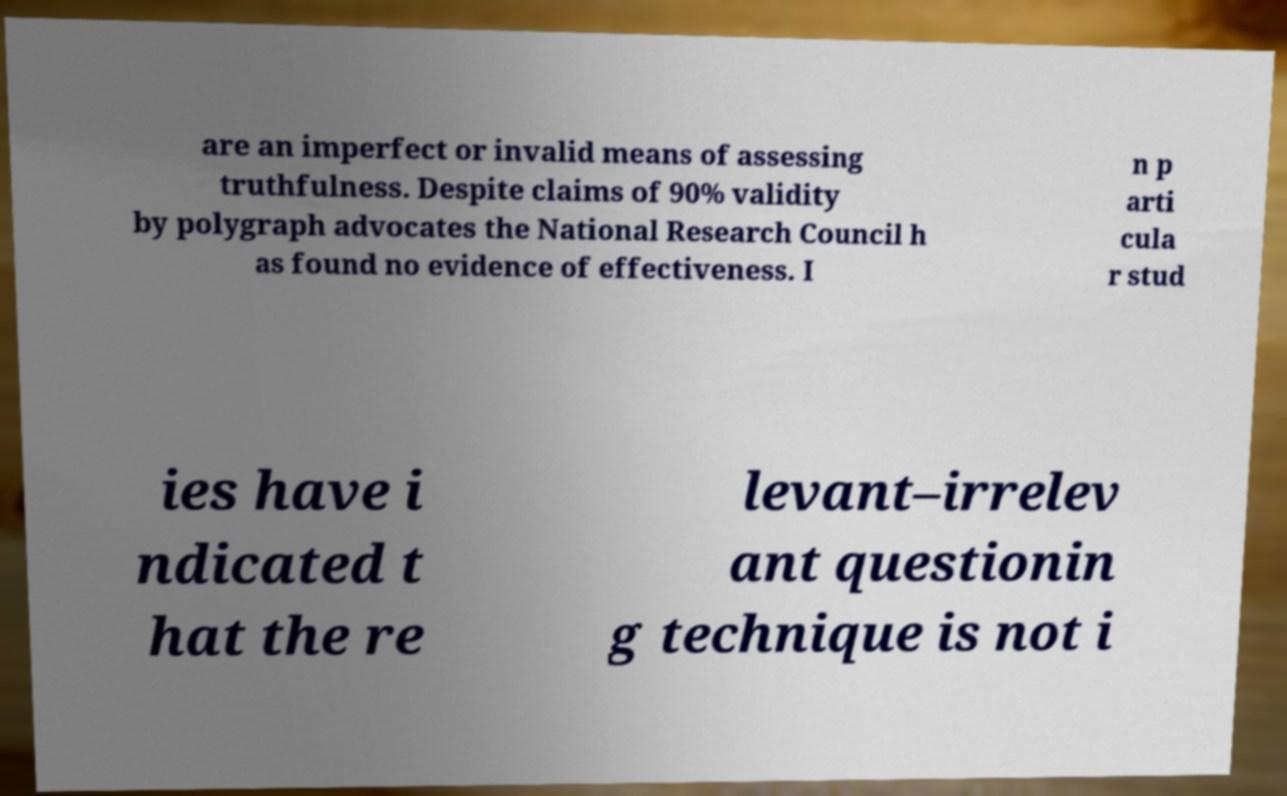For documentation purposes, I need the text within this image transcribed. Could you provide that? are an imperfect or invalid means of assessing truthfulness. Despite claims of 90% validity by polygraph advocates the National Research Council h as found no evidence of effectiveness. I n p arti cula r stud ies have i ndicated t hat the re levant–irrelev ant questionin g technique is not i 